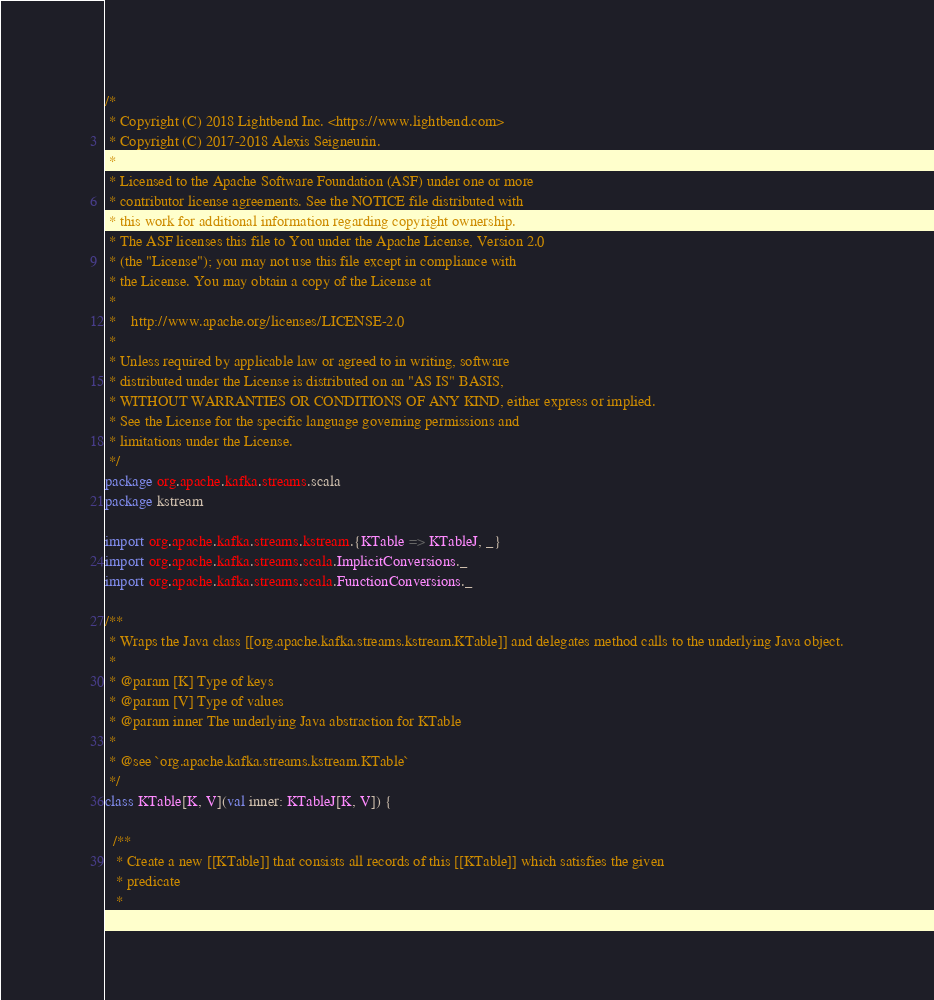<code> <loc_0><loc_0><loc_500><loc_500><_Scala_>/*
 * Copyright (C) 2018 Lightbend Inc. <https://www.lightbend.com>
 * Copyright (C) 2017-2018 Alexis Seigneurin.
 *
 * Licensed to the Apache Software Foundation (ASF) under one or more
 * contributor license agreements. See the NOTICE file distributed with
 * this work for additional information regarding copyright ownership.
 * The ASF licenses this file to You under the Apache License, Version 2.0
 * (the "License"); you may not use this file except in compliance with
 * the License. You may obtain a copy of the License at
 *
 *    http://www.apache.org/licenses/LICENSE-2.0
 *
 * Unless required by applicable law or agreed to in writing, software
 * distributed under the License is distributed on an "AS IS" BASIS,
 * WITHOUT WARRANTIES OR CONDITIONS OF ANY KIND, either express or implied.
 * See the License for the specific language governing permissions and
 * limitations under the License.
 */
package org.apache.kafka.streams.scala
package kstream

import org.apache.kafka.streams.kstream.{KTable => KTableJ, _}
import org.apache.kafka.streams.scala.ImplicitConversions._
import org.apache.kafka.streams.scala.FunctionConversions._

/**
 * Wraps the Java class [[org.apache.kafka.streams.kstream.KTable]] and delegates method calls to the underlying Java object.
 *
 * @param [K] Type of keys
 * @param [V] Type of values
 * @param inner The underlying Java abstraction for KTable
 *
 * @see `org.apache.kafka.streams.kstream.KTable`
 */
class KTable[K, V](val inner: KTableJ[K, V]) {

  /**
   * Create a new [[KTable]] that consists all records of this [[KTable]] which satisfies the given
   * predicate
   *</code> 